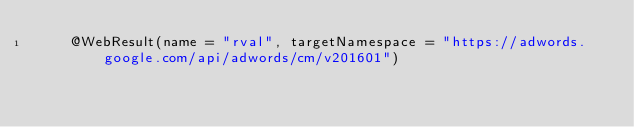<code> <loc_0><loc_0><loc_500><loc_500><_Java_>    @WebResult(name = "rval", targetNamespace = "https://adwords.google.com/api/adwords/cm/v201601")</code> 